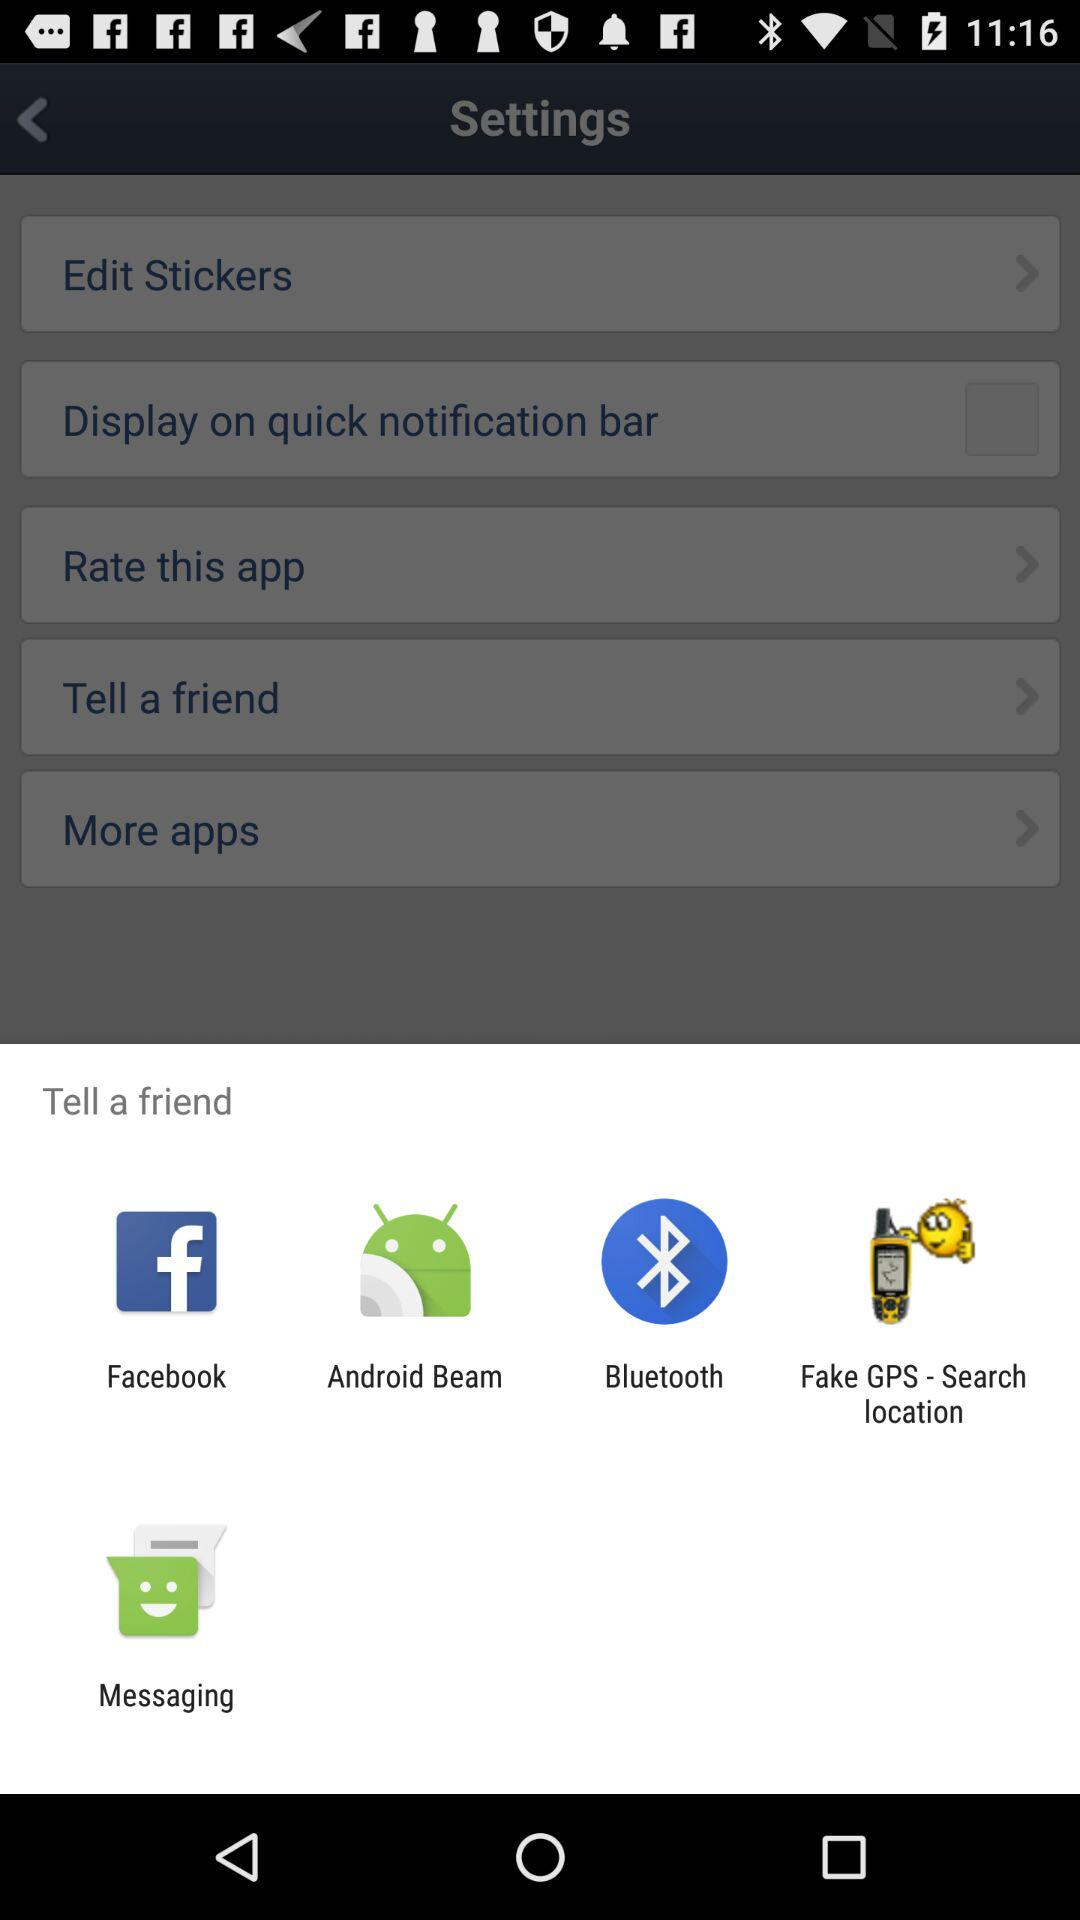Which applications can be used to tell a friend? The applications are "Facebook", "Android Beam", "Bluetooth", "Fake GPS - Search location" and "Messaging". 